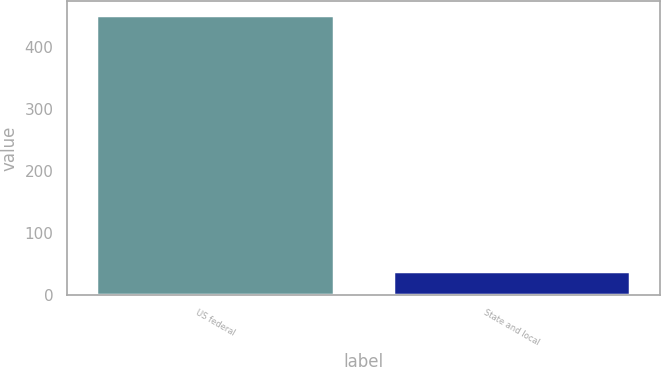Convert chart. <chart><loc_0><loc_0><loc_500><loc_500><bar_chart><fcel>US federal<fcel>State and local<nl><fcel>451<fcel>38<nl></chart> 